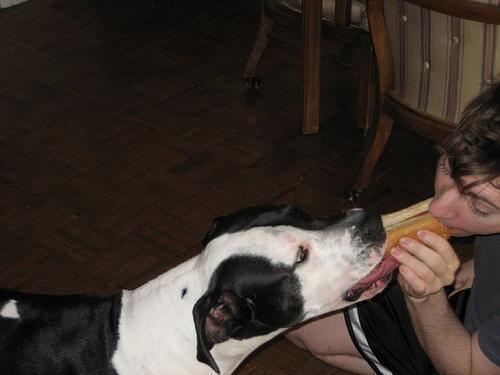How many dogs are there?
Give a very brief answer. 1. How many chairs can be seen?
Give a very brief answer. 2. 